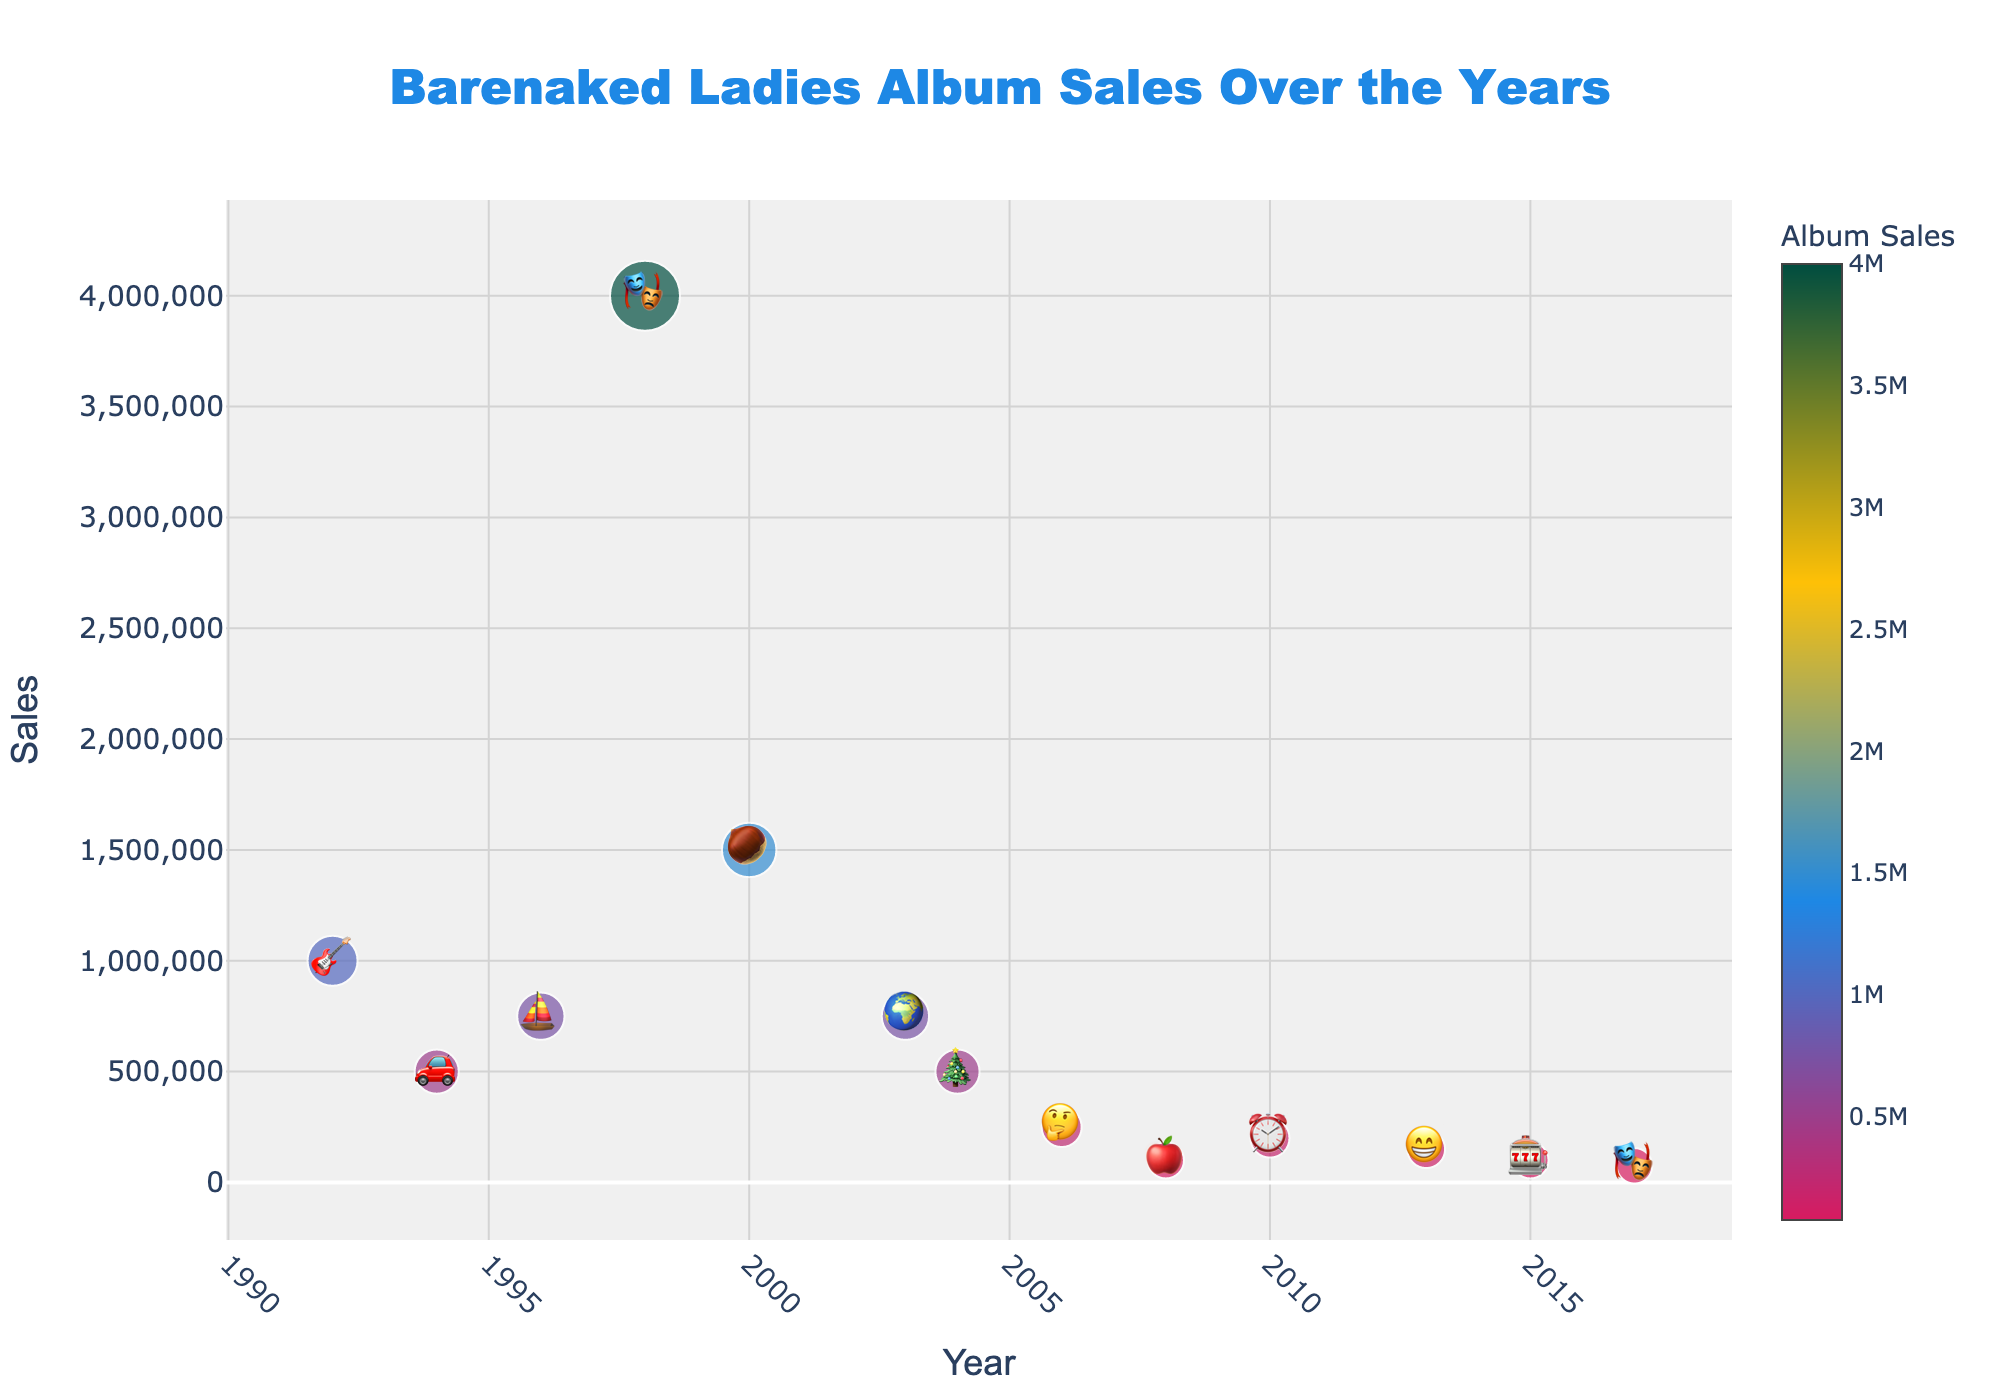What is the highest-selling Barenaked Ladies album? The highest point on the y-axis, which represents sales, is reached by the album "Stunt" in 1998 with the emoji 🎭. The y-axis label next to 🎭 is at 4,000,000.
Answer: Stunt Which album was released in the year 2000 and what are its sales? By locating the year 2000 on the x-axis, there's an emoji 🌰 above it. The hovertext for this album, labeled Maroon, shows sales of 1,500,000.
Answer: Maroon, 1,500,000 How does the sales of "Born on a Pirate Ship" compare to "Gordon"? For "Born on a Pirate Ship" (⛵ in 1996), the sales are 750,000. "Gordon" (🎸 in 1992) has sales of 1,000,000. Comparison shows Gordon sold more.
Answer: Gordon has higher sales Which albums have sales less than 200,000? Identifying data points below 200,000, we see two emojis: 🍎 for Snacktime! (100,000 in 2008) and 🎰 for Silverball (100,000 in 2015). The clock emoji ⏰ for All in Good Time (200,000 in 2010), however, is equal, not less. Thus, only two albums meet the criteria.
Answer: Snacktime! and Silverball By how much did "Grinning Streak" sales differ from "All in Good Time"? Finding 😁 for Grinning Streak (150,000 in 2013) and ⏰ for All in Good Time (200,000 in 2010) on the chart, the difference in their sales is 200,000 - 150,000 = 50,000.
Answer: 50,000 What is the average sales figure for albums released before 2000? Calculating sales for 🎸 (Gordon, 1992, 1,000,000), 🚗 (Maybe You Should Drive, 1994, 500,000), and ⛵ (Born on a Pirate Ship, 1996, 750,000), we get (1,000,000 + 500,000 + 750,000) / 3 = 750,000.
Answer: 750,000 